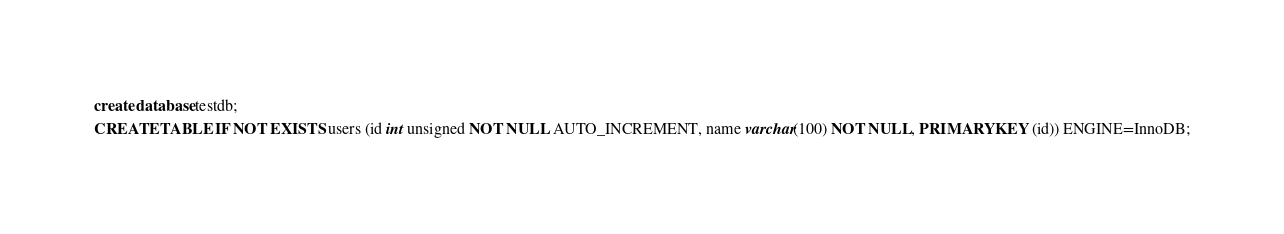Convert code to text. <code><loc_0><loc_0><loc_500><loc_500><_SQL_>create database testdb;
CREATE TABLE IF NOT EXISTS users (id int unsigned NOT NULL AUTO_INCREMENT, name varchar(100) NOT NULL, PRIMARY KEY (id)) ENGINE=InnoDB;</code> 